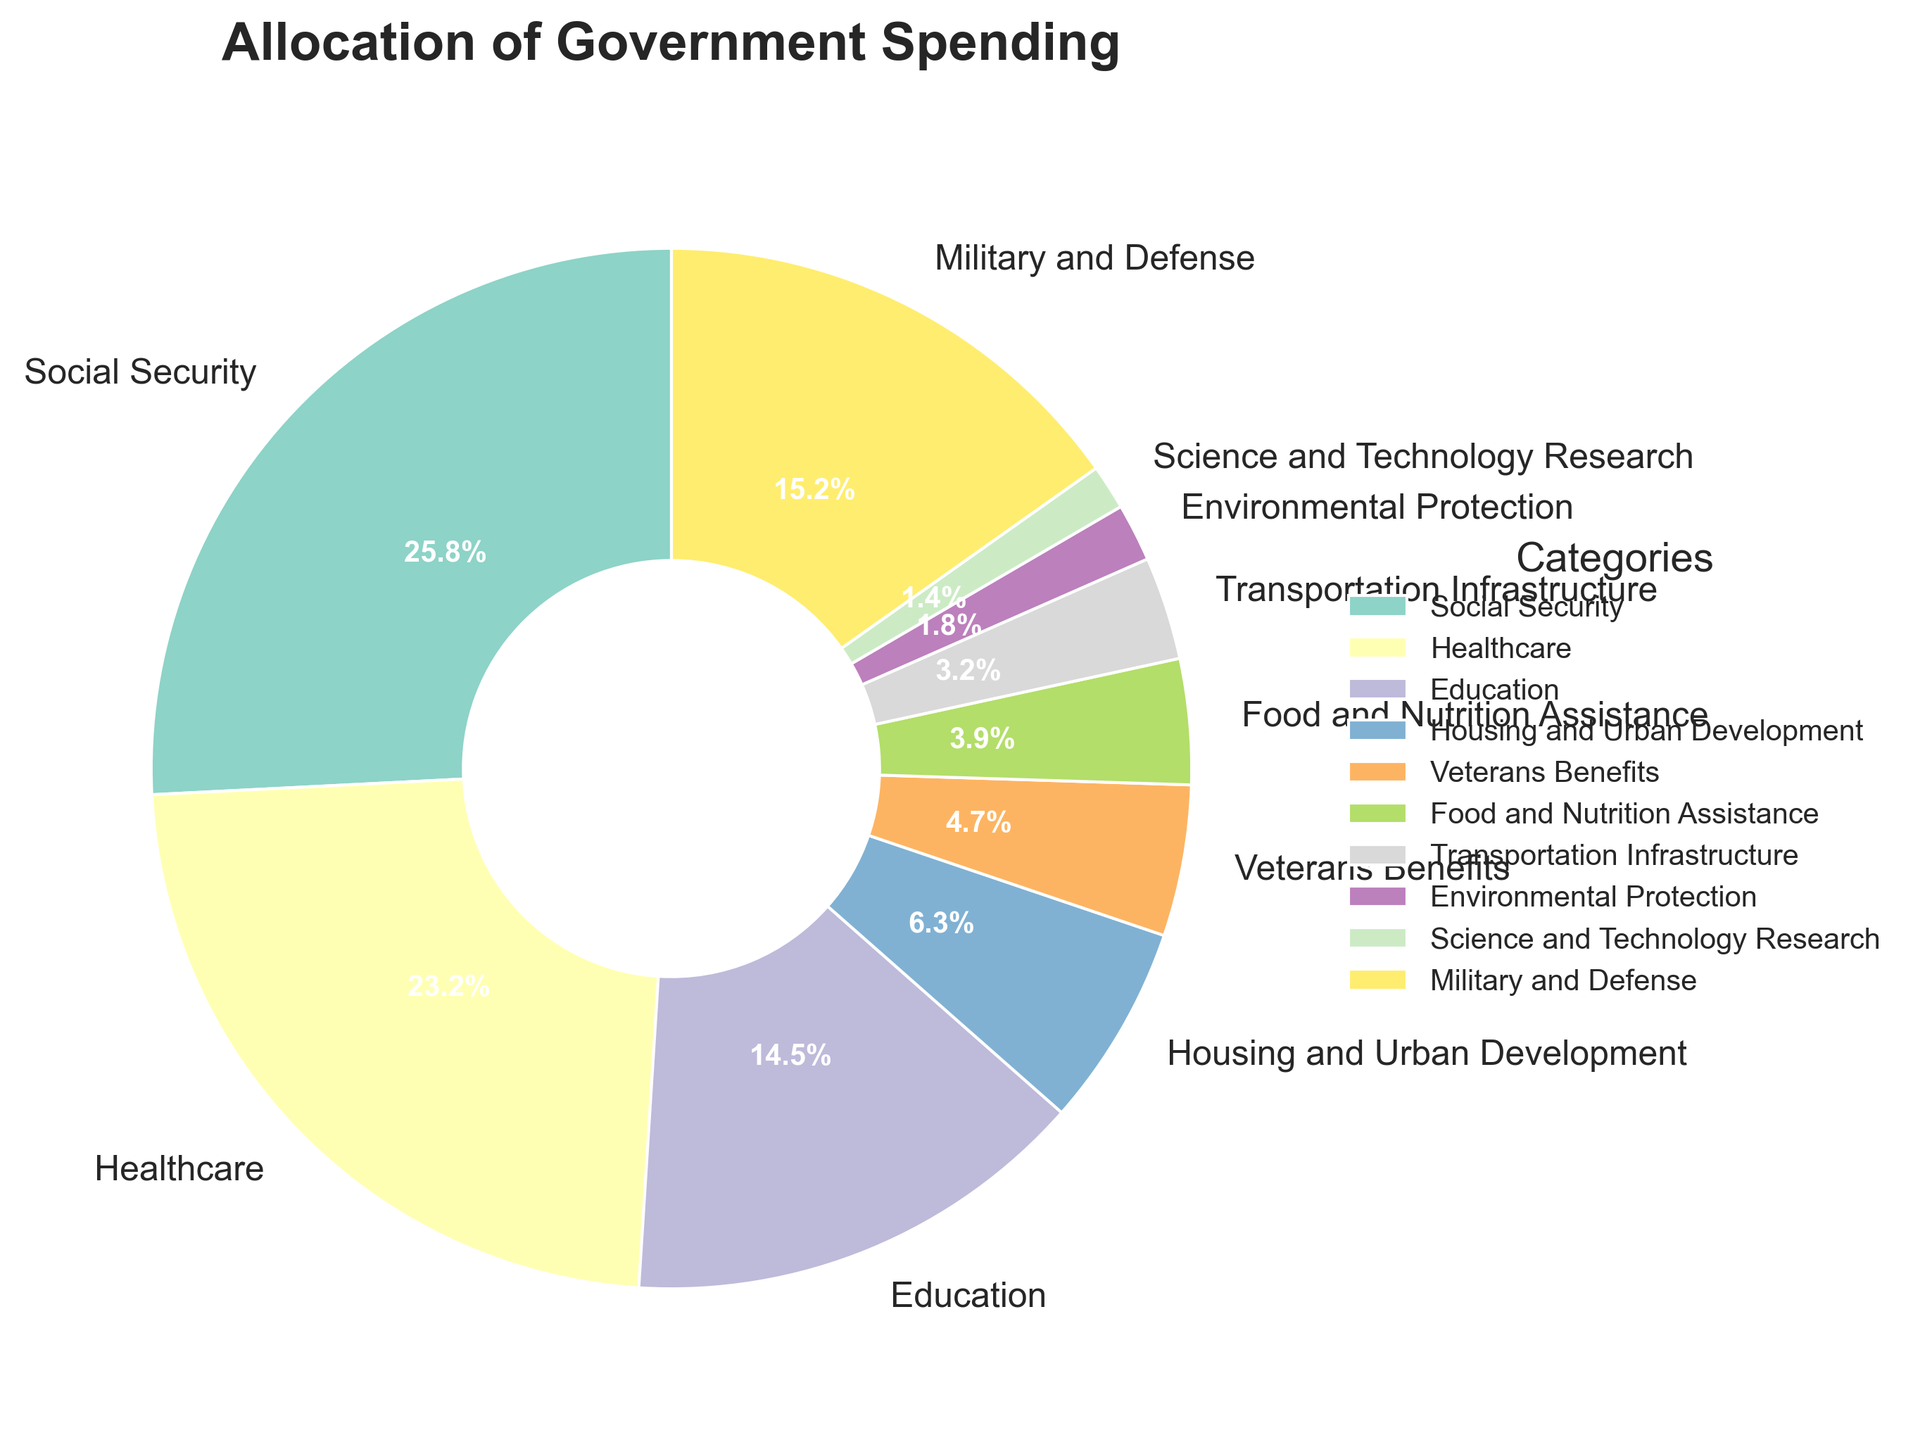What's the total percentage of government spending allocated to Social Security, Healthcare, and Education combined? To find the total percentage, sum the individual percentages for Social Security (25.8%), Healthcare (23.2%), and Education (14.5%). The calculation is 25.8 + 23.2 + 14.5 = 63.5.
Answer: 63.5% Which category receives more government spending, Military and Defense or Education? The percentage for Military and Defense is 15.2%, while Education is 14.5%. Since 15.2 > 14.5, Military and Defense receives more.
Answer: Military and Defense What is the difference in percentage between spending on Healthcare and Military and Defense? The percentage for Healthcare is 23.2% and for Military and Defense is 15.2%. The difference is 23.2 - 15.2 = 8.
Answer: 8 What is the combined percentage of spending on Veterans Benefits and Food and Nutrition Assistance? Sum the percentages for Veterans Benefits (4.7%) and Food and Nutrition Assistance (3.9%). The calculation is 4.7 + 3.9 = 8.6.
Answer: 8.6% Which category has the smallest allocation, and what is it? From the pie chart, Science and Technology Research has the smallest allocation at 1.4%.
Answer: Science and Technology Research, 1.4% How much more (in percentage terms) is spent on Transportation Infrastructure compared to Environmental Protection? The percentage for Transportation Infrastructure is 3.2% and for Environmental Protection is 1.8%. The excess spending is 3.2 - 1.8 = 1.4.
Answer: 1.4 Is government spending on Housing and Urban Development more than on Veterans Benefits? The percentage for Housing and Urban Development is 6.3%, and for Veterans Benefits, it is 4.7%. Since 6.3 > 4.7, spending on Housing and Urban Development is more.
Answer: Yes Combined, do Transportation Infrastructure and Science and Technology Research receive more or less funding than Housing and Urban Development? The combined percentage for Transportation Infrastructure (3.2%) and Science and Technology Research (1.4%) is 3.2 + 1.4 = 4.6%. Housing and Urban Development receives 6.3%. Since 4.6 < 6.3, they receive less funding.
Answer: Less Which category has a higher percentage allocation: Environmental Protection or Food and Nutrition Assistance? The percentage for Environmental Protection is 1.8%, and for Food and Nutrition Assistance, it is 3.9%. Since 3.9 > 1.8, Food and Nutrition Assistance has a higher allocation.
Answer: Food and Nutrition Assistance 